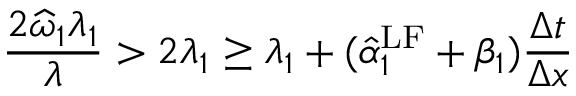<formula> <loc_0><loc_0><loc_500><loc_500>\frac { 2 \widehat { \omega } _ { 1 } \lambda _ { 1 } } { \lambda } > 2 \lambda _ { 1 } \geq \lambda _ { 1 } + ( \hat { \alpha } _ { 1 } ^ { L F } + \beta _ { 1 } ) \frac { \Delta t } { \Delta x }</formula> 